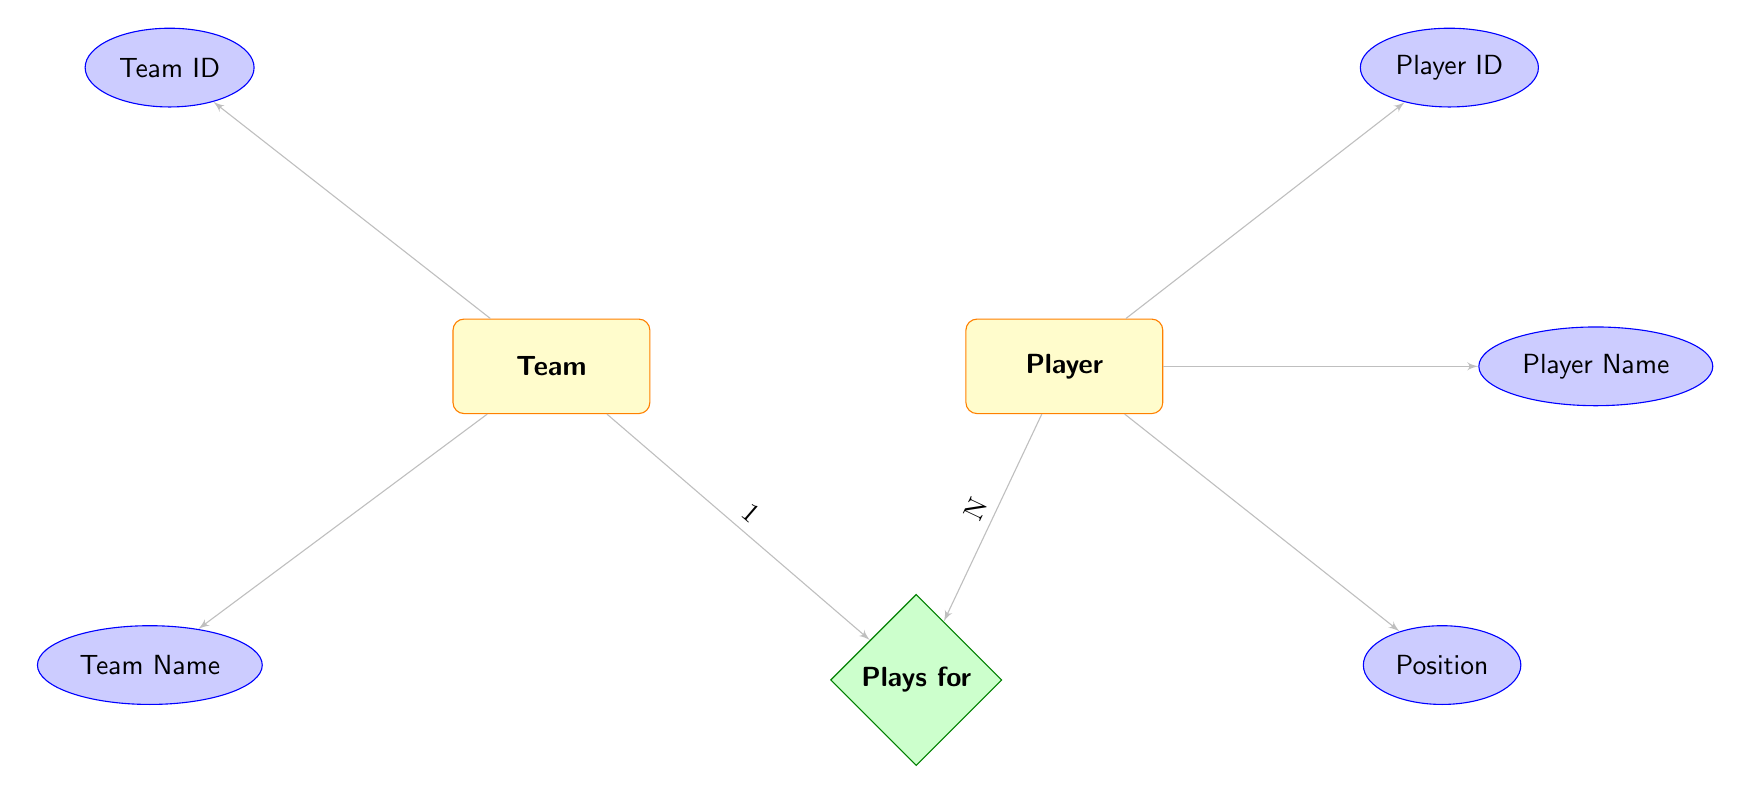What are the teams represented in the diagram? The diagram contains two nodes representing the entities. The "Team" entity is represented and linked to players. The data shows three teams: Cibona Zagreb, Zadar, and Split.
Answer: Cibona Zagreb, Zadar, Split How many players are associated with the team "Zadar"? To find the number of players associated with "Zadar", look at the "Players" attribute linked to the team node. "Zadar" has two players: Dominik Mavra and Aleksandar Bursać.
Answer: 2 What position does Leo Menalo play? In the diagram, each player node contains an attribute called "Position". Leo Menalo is linked to the "Position" attribute which is identified as "Forward".
Answer: Forward Which team does Roko Prkačin play for? To determine the team Roko Prkačin plays for, check the team associated with his "Player" node. The data shows he is linked to the team Cibona Zagreb.
Answer: Cibona Zagreb How many total relationships are shown in the diagram? The relationships between "Team" and "Player" entities are counted in the relationship node labeled "Plays for". Each team can have multiple players, and the total relationships visible in this diagram corresponds to the number of players across teams. There are 5 player nodes, leading to 5 direct relationships.
Answer: 5 Which player has the ID 3? The identification process involves checking the player entities listed in the data. The player node with ID 3 corresponds to Dominik Mavra.
Answer: Dominik Mavra What is the relationship type between Teams and Players? The relationship in the diagram is labeled as "Plays for", indicating that players belong to respective teams. This relationship is foundational in the structure of the diagram.
Answer: Plays for How many players are classed as Guards in the diagram? Counting players in the diagram under the "Position" attribute, there are two Guards: Mislav Brzoja and Dominik Mavra, making the total count of Guards equal to 2.
Answer: 2 